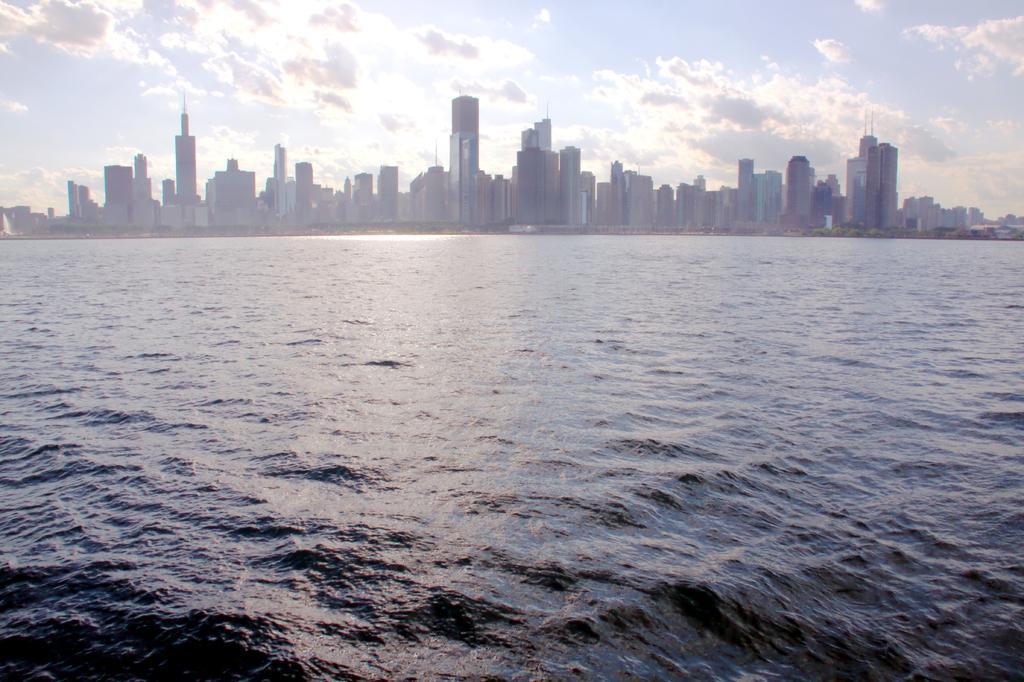In one or two sentences, can you explain what this image depicts? In this picture we can see water, buildings and skyscrapers. Behind the skyscrapers there is a sky. 